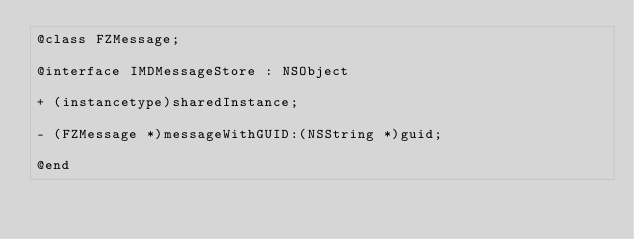Convert code to text. <code><loc_0><loc_0><loc_500><loc_500><_C_>@class FZMessage;

@interface IMDMessageStore : NSObject

+ (instancetype)sharedInstance;

- (FZMessage *)messageWithGUID:(NSString *)guid;

@end
</code> 